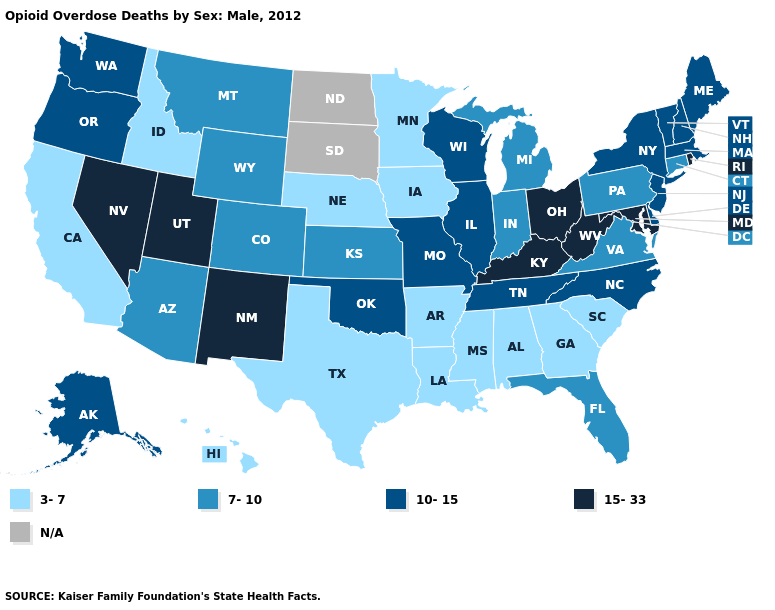Does the map have missing data?
Answer briefly. Yes. Which states have the lowest value in the USA?
Answer briefly. Alabama, Arkansas, California, Georgia, Hawaii, Idaho, Iowa, Louisiana, Minnesota, Mississippi, Nebraska, South Carolina, Texas. What is the value of Kentucky?
Keep it brief. 15-33. Among the states that border Wyoming , does Colorado have the highest value?
Concise answer only. No. Which states have the lowest value in the USA?
Keep it brief. Alabama, Arkansas, California, Georgia, Hawaii, Idaho, Iowa, Louisiana, Minnesota, Mississippi, Nebraska, South Carolina, Texas. Name the states that have a value in the range 7-10?
Give a very brief answer. Arizona, Colorado, Connecticut, Florida, Indiana, Kansas, Michigan, Montana, Pennsylvania, Virginia, Wyoming. Among the states that border Arkansas , which have the highest value?
Give a very brief answer. Missouri, Oklahoma, Tennessee. Does Nevada have the lowest value in the USA?
Give a very brief answer. No. How many symbols are there in the legend?
Keep it brief. 5. Does South Carolina have the highest value in the South?
Answer briefly. No. Among the states that border Wisconsin , does Illinois have the lowest value?
Quick response, please. No. Which states hav the highest value in the Northeast?
Keep it brief. Rhode Island. Which states have the highest value in the USA?
Short answer required. Kentucky, Maryland, Nevada, New Mexico, Ohio, Rhode Island, Utah, West Virginia. 